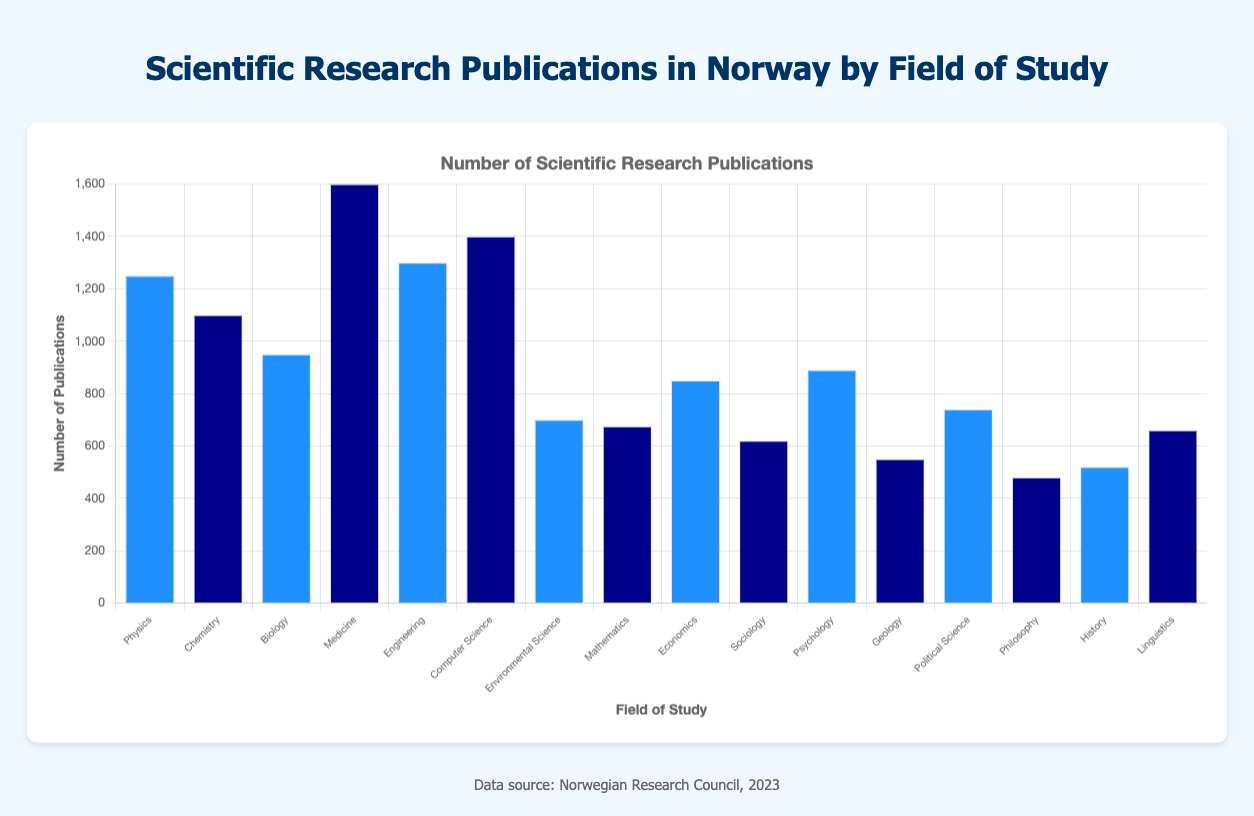Which field of study has the highest number of publications? By looking at the height of the bars, Medicine has the tallest bar, which indicates it has the highest number of publications.
Answer: Medicine Which field has more publications, Computer Science or Engineering? To compare the heights of the bars, Computer Science's bar is taller than Engineering's bar, meaning Computer Science has more publications.
Answer: Computer Science What is the difference in the number of publications between Psychology and Sociology? Subtract the number of publications of Sociology from Psychology: 890 - 620 = 270
Answer: 270 What is the combined number of publications for the fields related to social sciences (Economics, Sociology, Political Science, and Psychology)? Add the number of publications for Economics (850), Sociology (620), Political Science (740), and Psychology (890): 850 + 620 + 740 + 890 = 3100
Answer: 3100 Which field has fewer publications, Geology or History? Comparing the heights of the bars, Geology has a shorter bar than History, indicating Geology has fewer publications.
Answer: Geology What is the average number of publications for the fields listed in the figure? Sum all publications: 1250 + 1100 + 950 + 1600 + 1300 + 1400 + 700 + 675 + 850 + 620 + 890 + 550 + 740 + 480 + 520 + 660 = 16285, and divide by the number of fields (16): 16285 / 16 = 1017.81
Answer: 1017.81 Is the number of Chemistry publications closer to Medicine or Physics? Compare the difference in the number of publications: Chemistry and Medicine difference: 1600 - 1100 = 500, Chemistry and Physics difference: 1250 - 1100 = 150. Chemistry is closer to Physics.
Answer: Physics Which field has exactly 700 publications as indicated by its bar height? Environmental Science has exactly 700 publications as shown by its bar.
Answer: Environmental Science How many more publications does Computer Science have compared to Biology? Subtract the number of Biology publications from Computer Science publications: 1400 - 950 = 450
Answer: 450 What is the sum of the publications for the fields whose bars are colored "blue"? Sum the publications for Physics (1250), Biology (950), Engineering (1300), Environmental Science (700), Economics (850), Psychology (890), Political Science (740), and History (520): 1250 + 950 + 1300 + 700 + 850 + 890 + 740 + 520 = 7200
Answer: 7200 